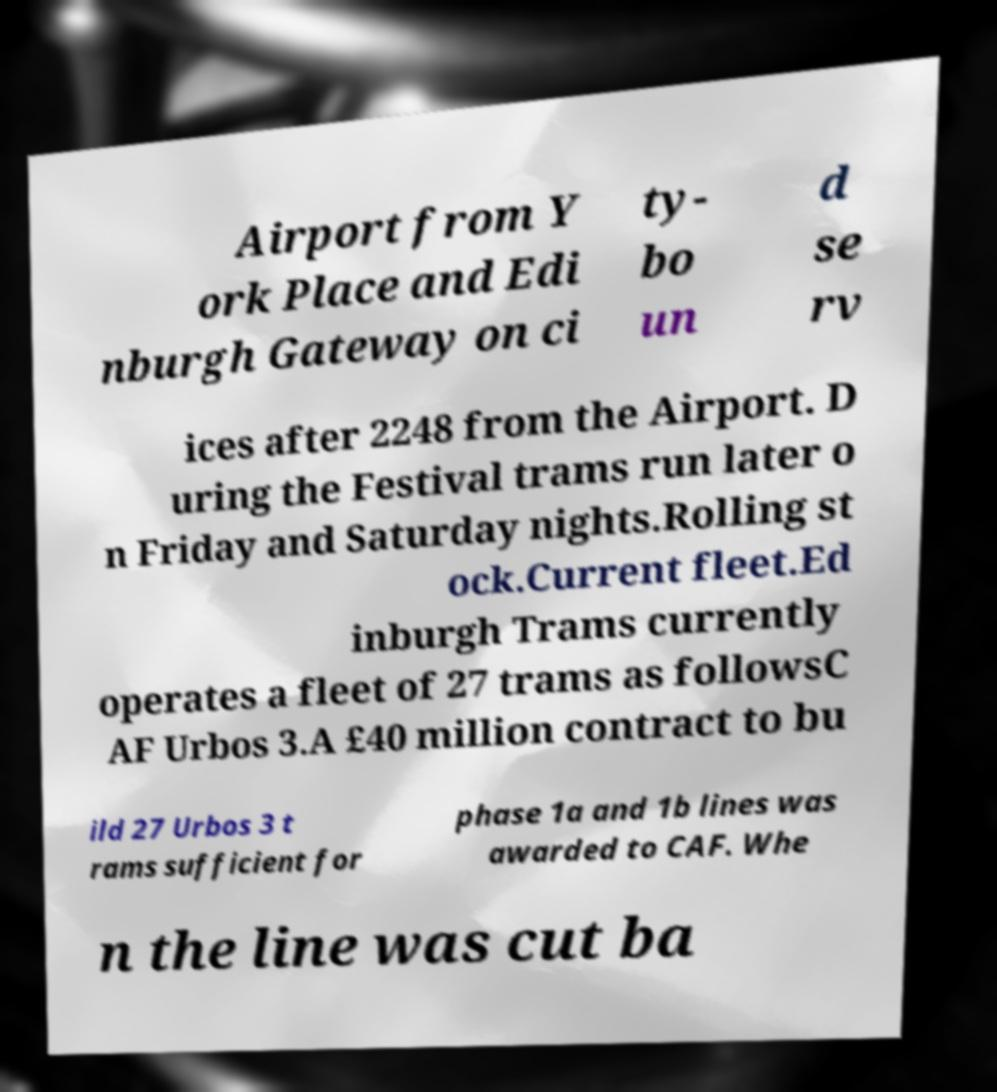For documentation purposes, I need the text within this image transcribed. Could you provide that? Airport from Y ork Place and Edi nburgh Gateway on ci ty- bo un d se rv ices after 2248 from the Airport. D uring the Festival trams run later o n Friday and Saturday nights.Rolling st ock.Current fleet.Ed inburgh Trams currently operates a fleet of 27 trams as followsC AF Urbos 3.A £40 million contract to bu ild 27 Urbos 3 t rams sufficient for phase 1a and 1b lines was awarded to CAF. Whe n the line was cut ba 